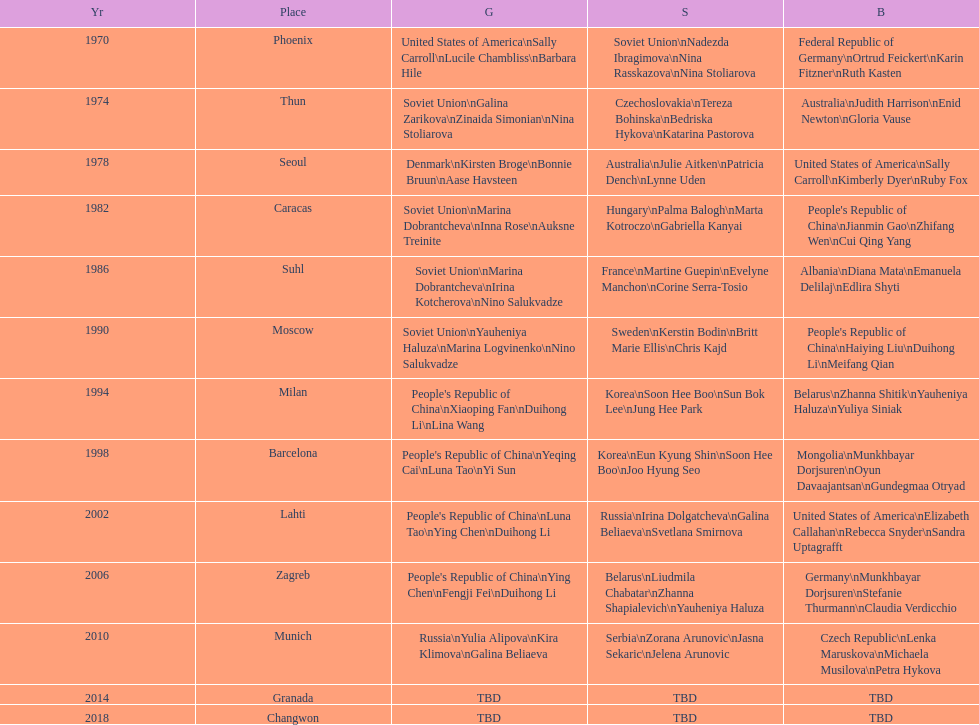Whose name is listed before bonnie bruun's in the gold column? Kirsten Broge. 